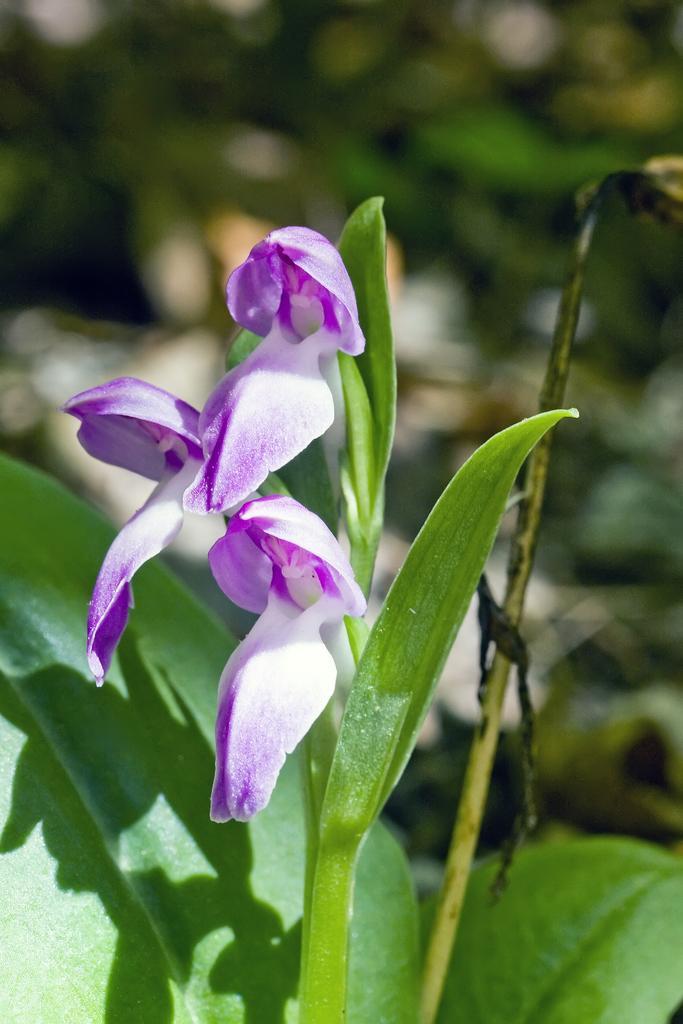In one or two sentences, can you explain what this image depicts? Here I can see a plant along with the flowers and leaves. The flowers are in violet and white colors. The background is blurred. 